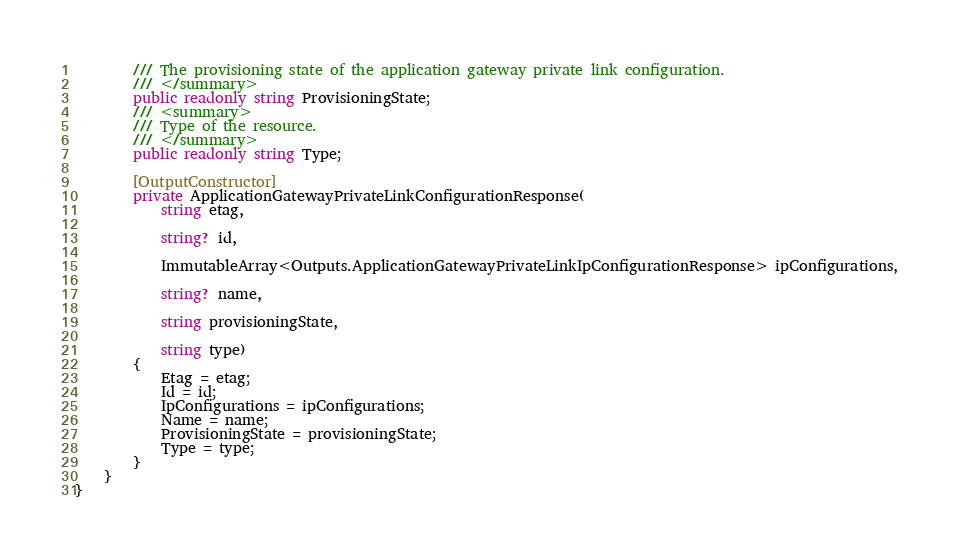<code> <loc_0><loc_0><loc_500><loc_500><_C#_>        /// The provisioning state of the application gateway private link configuration.
        /// </summary>
        public readonly string ProvisioningState;
        /// <summary>
        /// Type of the resource.
        /// </summary>
        public readonly string Type;

        [OutputConstructor]
        private ApplicationGatewayPrivateLinkConfigurationResponse(
            string etag,

            string? id,

            ImmutableArray<Outputs.ApplicationGatewayPrivateLinkIpConfigurationResponse> ipConfigurations,

            string? name,

            string provisioningState,

            string type)
        {
            Etag = etag;
            Id = id;
            IpConfigurations = ipConfigurations;
            Name = name;
            ProvisioningState = provisioningState;
            Type = type;
        }
    }
}
</code> 